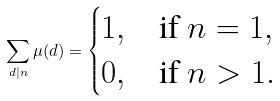<formula> <loc_0><loc_0><loc_500><loc_500>\sum _ { d | n } \mu ( d ) = \begin{cases} 1 , & \text {if } n = 1 , \\ 0 , & \text {if } n > 1 . \end{cases}</formula> 